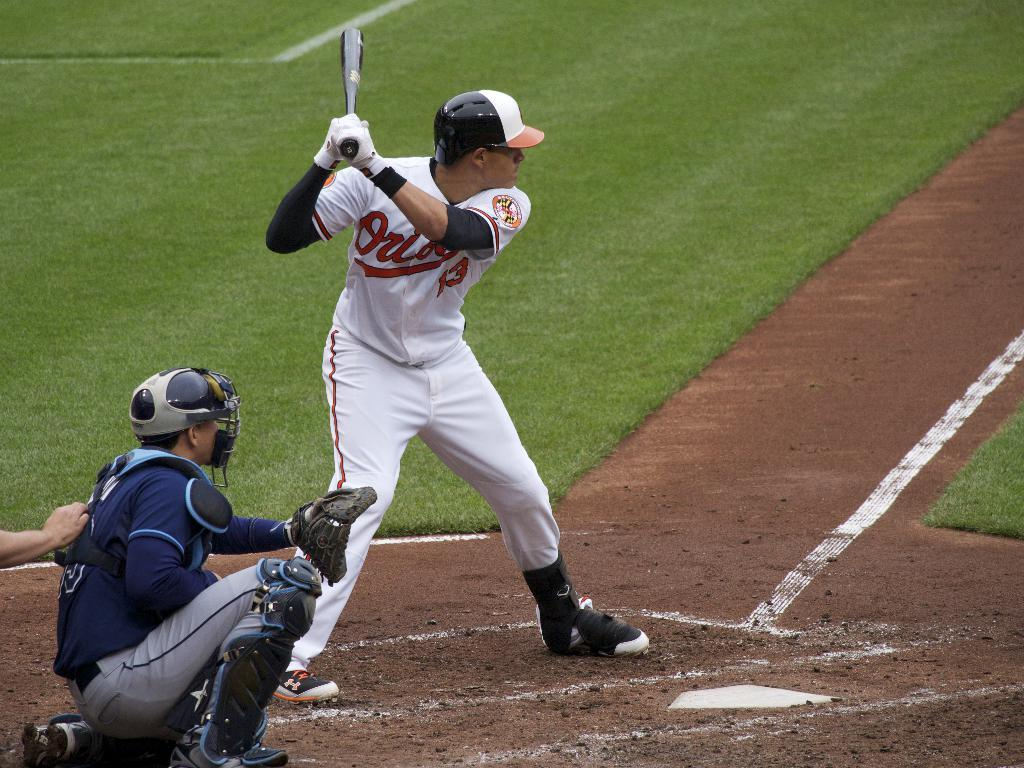<image>
Offer a succinct explanation of the picture presented. An Orioles player who wears number 13 gets ready to hit a pitch 